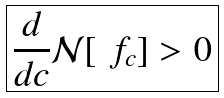<formula> <loc_0><loc_0><loc_500><loc_500>\boxed { \frac { d } { d c } \mathcal { N } [ \ f _ { c } ] > 0 }</formula> 